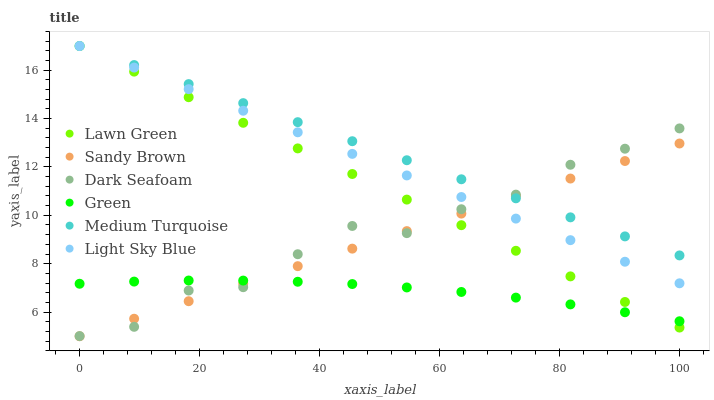Does Green have the minimum area under the curve?
Answer yes or no. Yes. Does Medium Turquoise have the maximum area under the curve?
Answer yes or no. Yes. Does Dark Seafoam have the minimum area under the curve?
Answer yes or no. No. Does Dark Seafoam have the maximum area under the curve?
Answer yes or no. No. Is Light Sky Blue the smoothest?
Answer yes or no. Yes. Is Dark Seafoam the roughest?
Answer yes or no. Yes. Is Dark Seafoam the smoothest?
Answer yes or no. No. Is Light Sky Blue the roughest?
Answer yes or no. No. Does Sandy Brown have the lowest value?
Answer yes or no. Yes. Does Dark Seafoam have the lowest value?
Answer yes or no. No. Does Medium Turquoise have the highest value?
Answer yes or no. Yes. Does Dark Seafoam have the highest value?
Answer yes or no. No. Is Green less than Light Sky Blue?
Answer yes or no. Yes. Is Medium Turquoise greater than Green?
Answer yes or no. Yes. Does Dark Seafoam intersect Lawn Green?
Answer yes or no. Yes. Is Dark Seafoam less than Lawn Green?
Answer yes or no. No. Is Dark Seafoam greater than Lawn Green?
Answer yes or no. No. Does Green intersect Light Sky Blue?
Answer yes or no. No. 